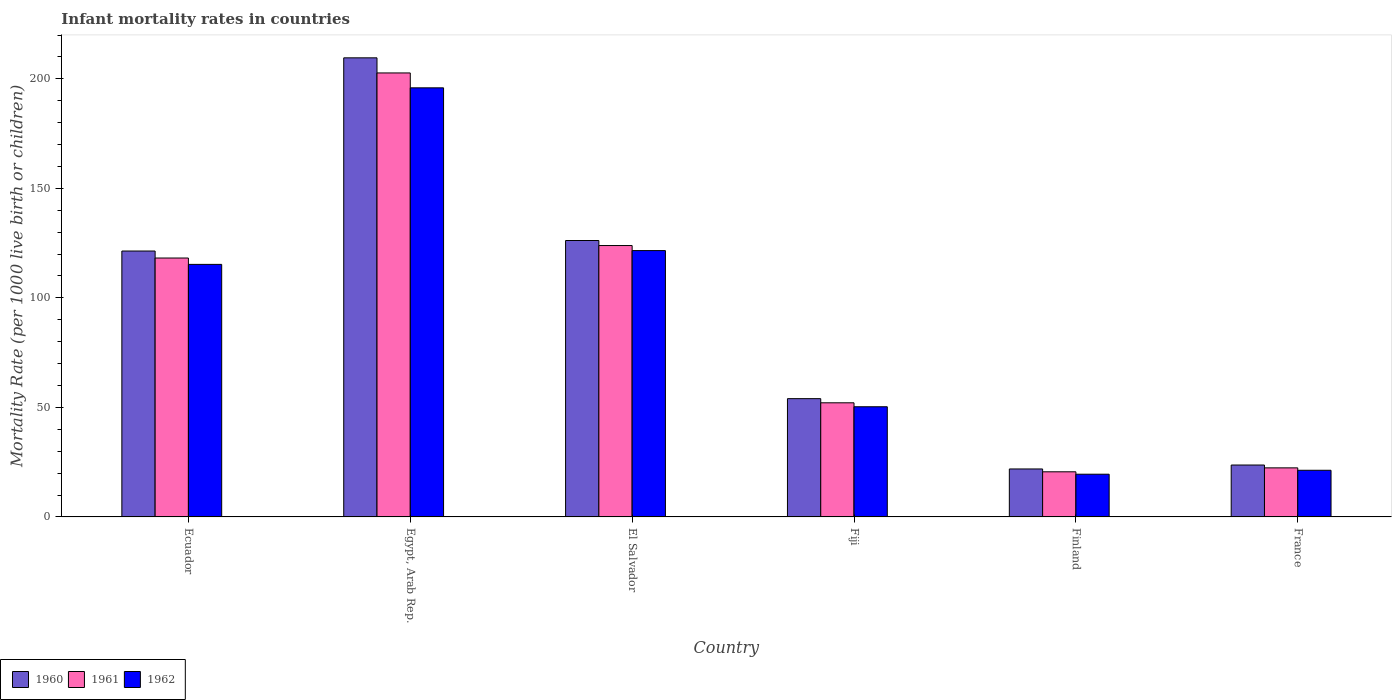How many different coloured bars are there?
Give a very brief answer. 3. How many groups of bars are there?
Keep it short and to the point. 6. Are the number of bars per tick equal to the number of legend labels?
Your answer should be compact. Yes. How many bars are there on the 4th tick from the left?
Provide a short and direct response. 3. How many bars are there on the 1st tick from the right?
Ensure brevity in your answer.  3. In how many cases, is the number of bars for a given country not equal to the number of legend labels?
Provide a succinct answer. 0. What is the infant mortality rate in 1962 in Egypt, Arab Rep.?
Your response must be concise. 195.9. Across all countries, what is the maximum infant mortality rate in 1960?
Your response must be concise. 209.6. Across all countries, what is the minimum infant mortality rate in 1961?
Give a very brief answer. 20.6. In which country was the infant mortality rate in 1961 maximum?
Your response must be concise. Egypt, Arab Rep. In which country was the infant mortality rate in 1962 minimum?
Offer a terse response. Finland. What is the total infant mortality rate in 1960 in the graph?
Offer a terse response. 556.8. What is the difference between the infant mortality rate in 1960 in El Salvador and that in Fiji?
Offer a very short reply. 72.2. What is the difference between the infant mortality rate in 1962 in El Salvador and the infant mortality rate in 1960 in Fiji?
Provide a succinct answer. 67.6. What is the average infant mortality rate in 1961 per country?
Your answer should be compact. 89.98. What is the difference between the infant mortality rate of/in 1961 and infant mortality rate of/in 1962 in Finland?
Give a very brief answer. 1.1. What is the ratio of the infant mortality rate in 1962 in Egypt, Arab Rep. to that in Finland?
Ensure brevity in your answer.  10.05. Is the infant mortality rate in 1962 in Ecuador less than that in El Salvador?
Provide a short and direct response. Yes. What is the difference between the highest and the second highest infant mortality rate in 1961?
Ensure brevity in your answer.  78.8. What is the difference between the highest and the lowest infant mortality rate in 1961?
Offer a very short reply. 182.1. What does the 1st bar from the left in Finland represents?
Your answer should be very brief. 1960. What does the 1st bar from the right in France represents?
Give a very brief answer. 1962. How many countries are there in the graph?
Keep it short and to the point. 6. Does the graph contain grids?
Keep it short and to the point. No. Where does the legend appear in the graph?
Offer a terse response. Bottom left. How are the legend labels stacked?
Make the answer very short. Horizontal. What is the title of the graph?
Offer a terse response. Infant mortality rates in countries. Does "1983" appear as one of the legend labels in the graph?
Provide a succinct answer. No. What is the label or title of the X-axis?
Provide a short and direct response. Country. What is the label or title of the Y-axis?
Provide a succinct answer. Mortality Rate (per 1000 live birth or children). What is the Mortality Rate (per 1000 live birth or children) of 1960 in Ecuador?
Ensure brevity in your answer.  121.4. What is the Mortality Rate (per 1000 live birth or children) of 1961 in Ecuador?
Your answer should be very brief. 118.2. What is the Mortality Rate (per 1000 live birth or children) of 1962 in Ecuador?
Offer a very short reply. 115.3. What is the Mortality Rate (per 1000 live birth or children) in 1960 in Egypt, Arab Rep.?
Ensure brevity in your answer.  209.6. What is the Mortality Rate (per 1000 live birth or children) in 1961 in Egypt, Arab Rep.?
Provide a short and direct response. 202.7. What is the Mortality Rate (per 1000 live birth or children) of 1962 in Egypt, Arab Rep.?
Offer a very short reply. 195.9. What is the Mortality Rate (per 1000 live birth or children) of 1960 in El Salvador?
Give a very brief answer. 126.2. What is the Mortality Rate (per 1000 live birth or children) of 1961 in El Salvador?
Keep it short and to the point. 123.9. What is the Mortality Rate (per 1000 live birth or children) of 1962 in El Salvador?
Offer a terse response. 121.6. What is the Mortality Rate (per 1000 live birth or children) of 1961 in Fiji?
Your response must be concise. 52.1. What is the Mortality Rate (per 1000 live birth or children) of 1962 in Fiji?
Ensure brevity in your answer.  50.3. What is the Mortality Rate (per 1000 live birth or children) of 1960 in Finland?
Keep it short and to the point. 21.9. What is the Mortality Rate (per 1000 live birth or children) of 1961 in Finland?
Give a very brief answer. 20.6. What is the Mortality Rate (per 1000 live birth or children) of 1960 in France?
Your response must be concise. 23.7. What is the Mortality Rate (per 1000 live birth or children) in 1961 in France?
Your answer should be very brief. 22.4. What is the Mortality Rate (per 1000 live birth or children) of 1962 in France?
Make the answer very short. 21.3. Across all countries, what is the maximum Mortality Rate (per 1000 live birth or children) in 1960?
Offer a terse response. 209.6. Across all countries, what is the maximum Mortality Rate (per 1000 live birth or children) in 1961?
Offer a terse response. 202.7. Across all countries, what is the maximum Mortality Rate (per 1000 live birth or children) in 1962?
Provide a short and direct response. 195.9. Across all countries, what is the minimum Mortality Rate (per 1000 live birth or children) of 1960?
Keep it short and to the point. 21.9. Across all countries, what is the minimum Mortality Rate (per 1000 live birth or children) of 1961?
Give a very brief answer. 20.6. Across all countries, what is the minimum Mortality Rate (per 1000 live birth or children) in 1962?
Provide a short and direct response. 19.5. What is the total Mortality Rate (per 1000 live birth or children) of 1960 in the graph?
Offer a terse response. 556.8. What is the total Mortality Rate (per 1000 live birth or children) of 1961 in the graph?
Make the answer very short. 539.9. What is the total Mortality Rate (per 1000 live birth or children) in 1962 in the graph?
Provide a short and direct response. 523.9. What is the difference between the Mortality Rate (per 1000 live birth or children) of 1960 in Ecuador and that in Egypt, Arab Rep.?
Your answer should be compact. -88.2. What is the difference between the Mortality Rate (per 1000 live birth or children) in 1961 in Ecuador and that in Egypt, Arab Rep.?
Your answer should be very brief. -84.5. What is the difference between the Mortality Rate (per 1000 live birth or children) in 1962 in Ecuador and that in Egypt, Arab Rep.?
Offer a very short reply. -80.6. What is the difference between the Mortality Rate (per 1000 live birth or children) of 1961 in Ecuador and that in El Salvador?
Your answer should be very brief. -5.7. What is the difference between the Mortality Rate (per 1000 live birth or children) in 1962 in Ecuador and that in El Salvador?
Offer a terse response. -6.3. What is the difference between the Mortality Rate (per 1000 live birth or children) of 1960 in Ecuador and that in Fiji?
Your answer should be compact. 67.4. What is the difference between the Mortality Rate (per 1000 live birth or children) in 1961 in Ecuador and that in Fiji?
Your answer should be compact. 66.1. What is the difference between the Mortality Rate (per 1000 live birth or children) of 1962 in Ecuador and that in Fiji?
Your answer should be very brief. 65. What is the difference between the Mortality Rate (per 1000 live birth or children) of 1960 in Ecuador and that in Finland?
Your answer should be compact. 99.5. What is the difference between the Mortality Rate (per 1000 live birth or children) of 1961 in Ecuador and that in Finland?
Give a very brief answer. 97.6. What is the difference between the Mortality Rate (per 1000 live birth or children) in 1962 in Ecuador and that in Finland?
Provide a short and direct response. 95.8. What is the difference between the Mortality Rate (per 1000 live birth or children) in 1960 in Ecuador and that in France?
Your response must be concise. 97.7. What is the difference between the Mortality Rate (per 1000 live birth or children) in 1961 in Ecuador and that in France?
Ensure brevity in your answer.  95.8. What is the difference between the Mortality Rate (per 1000 live birth or children) of 1962 in Ecuador and that in France?
Your answer should be very brief. 94. What is the difference between the Mortality Rate (per 1000 live birth or children) in 1960 in Egypt, Arab Rep. and that in El Salvador?
Make the answer very short. 83.4. What is the difference between the Mortality Rate (per 1000 live birth or children) in 1961 in Egypt, Arab Rep. and that in El Salvador?
Your answer should be very brief. 78.8. What is the difference between the Mortality Rate (per 1000 live birth or children) in 1962 in Egypt, Arab Rep. and that in El Salvador?
Your answer should be very brief. 74.3. What is the difference between the Mortality Rate (per 1000 live birth or children) in 1960 in Egypt, Arab Rep. and that in Fiji?
Your response must be concise. 155.6. What is the difference between the Mortality Rate (per 1000 live birth or children) in 1961 in Egypt, Arab Rep. and that in Fiji?
Your response must be concise. 150.6. What is the difference between the Mortality Rate (per 1000 live birth or children) in 1962 in Egypt, Arab Rep. and that in Fiji?
Your answer should be very brief. 145.6. What is the difference between the Mortality Rate (per 1000 live birth or children) in 1960 in Egypt, Arab Rep. and that in Finland?
Ensure brevity in your answer.  187.7. What is the difference between the Mortality Rate (per 1000 live birth or children) in 1961 in Egypt, Arab Rep. and that in Finland?
Keep it short and to the point. 182.1. What is the difference between the Mortality Rate (per 1000 live birth or children) of 1962 in Egypt, Arab Rep. and that in Finland?
Make the answer very short. 176.4. What is the difference between the Mortality Rate (per 1000 live birth or children) of 1960 in Egypt, Arab Rep. and that in France?
Your response must be concise. 185.9. What is the difference between the Mortality Rate (per 1000 live birth or children) in 1961 in Egypt, Arab Rep. and that in France?
Offer a very short reply. 180.3. What is the difference between the Mortality Rate (per 1000 live birth or children) of 1962 in Egypt, Arab Rep. and that in France?
Offer a very short reply. 174.6. What is the difference between the Mortality Rate (per 1000 live birth or children) in 1960 in El Salvador and that in Fiji?
Your answer should be very brief. 72.2. What is the difference between the Mortality Rate (per 1000 live birth or children) of 1961 in El Salvador and that in Fiji?
Ensure brevity in your answer.  71.8. What is the difference between the Mortality Rate (per 1000 live birth or children) of 1962 in El Salvador and that in Fiji?
Give a very brief answer. 71.3. What is the difference between the Mortality Rate (per 1000 live birth or children) of 1960 in El Salvador and that in Finland?
Offer a very short reply. 104.3. What is the difference between the Mortality Rate (per 1000 live birth or children) of 1961 in El Salvador and that in Finland?
Your answer should be compact. 103.3. What is the difference between the Mortality Rate (per 1000 live birth or children) in 1962 in El Salvador and that in Finland?
Your answer should be compact. 102.1. What is the difference between the Mortality Rate (per 1000 live birth or children) of 1960 in El Salvador and that in France?
Provide a succinct answer. 102.5. What is the difference between the Mortality Rate (per 1000 live birth or children) in 1961 in El Salvador and that in France?
Give a very brief answer. 101.5. What is the difference between the Mortality Rate (per 1000 live birth or children) of 1962 in El Salvador and that in France?
Your answer should be compact. 100.3. What is the difference between the Mortality Rate (per 1000 live birth or children) of 1960 in Fiji and that in Finland?
Give a very brief answer. 32.1. What is the difference between the Mortality Rate (per 1000 live birth or children) in 1961 in Fiji and that in Finland?
Keep it short and to the point. 31.5. What is the difference between the Mortality Rate (per 1000 live birth or children) in 1962 in Fiji and that in Finland?
Offer a very short reply. 30.8. What is the difference between the Mortality Rate (per 1000 live birth or children) in 1960 in Fiji and that in France?
Offer a terse response. 30.3. What is the difference between the Mortality Rate (per 1000 live birth or children) in 1961 in Fiji and that in France?
Ensure brevity in your answer.  29.7. What is the difference between the Mortality Rate (per 1000 live birth or children) of 1962 in Fiji and that in France?
Your answer should be compact. 29. What is the difference between the Mortality Rate (per 1000 live birth or children) in 1960 in Ecuador and the Mortality Rate (per 1000 live birth or children) in 1961 in Egypt, Arab Rep.?
Your answer should be compact. -81.3. What is the difference between the Mortality Rate (per 1000 live birth or children) of 1960 in Ecuador and the Mortality Rate (per 1000 live birth or children) of 1962 in Egypt, Arab Rep.?
Your answer should be very brief. -74.5. What is the difference between the Mortality Rate (per 1000 live birth or children) of 1961 in Ecuador and the Mortality Rate (per 1000 live birth or children) of 1962 in Egypt, Arab Rep.?
Provide a short and direct response. -77.7. What is the difference between the Mortality Rate (per 1000 live birth or children) of 1960 in Ecuador and the Mortality Rate (per 1000 live birth or children) of 1961 in El Salvador?
Your answer should be compact. -2.5. What is the difference between the Mortality Rate (per 1000 live birth or children) in 1960 in Ecuador and the Mortality Rate (per 1000 live birth or children) in 1962 in El Salvador?
Ensure brevity in your answer.  -0.2. What is the difference between the Mortality Rate (per 1000 live birth or children) in 1961 in Ecuador and the Mortality Rate (per 1000 live birth or children) in 1962 in El Salvador?
Your response must be concise. -3.4. What is the difference between the Mortality Rate (per 1000 live birth or children) in 1960 in Ecuador and the Mortality Rate (per 1000 live birth or children) in 1961 in Fiji?
Ensure brevity in your answer.  69.3. What is the difference between the Mortality Rate (per 1000 live birth or children) of 1960 in Ecuador and the Mortality Rate (per 1000 live birth or children) of 1962 in Fiji?
Make the answer very short. 71.1. What is the difference between the Mortality Rate (per 1000 live birth or children) of 1961 in Ecuador and the Mortality Rate (per 1000 live birth or children) of 1962 in Fiji?
Keep it short and to the point. 67.9. What is the difference between the Mortality Rate (per 1000 live birth or children) of 1960 in Ecuador and the Mortality Rate (per 1000 live birth or children) of 1961 in Finland?
Give a very brief answer. 100.8. What is the difference between the Mortality Rate (per 1000 live birth or children) of 1960 in Ecuador and the Mortality Rate (per 1000 live birth or children) of 1962 in Finland?
Give a very brief answer. 101.9. What is the difference between the Mortality Rate (per 1000 live birth or children) in 1961 in Ecuador and the Mortality Rate (per 1000 live birth or children) in 1962 in Finland?
Provide a succinct answer. 98.7. What is the difference between the Mortality Rate (per 1000 live birth or children) in 1960 in Ecuador and the Mortality Rate (per 1000 live birth or children) in 1961 in France?
Provide a short and direct response. 99. What is the difference between the Mortality Rate (per 1000 live birth or children) of 1960 in Ecuador and the Mortality Rate (per 1000 live birth or children) of 1962 in France?
Your response must be concise. 100.1. What is the difference between the Mortality Rate (per 1000 live birth or children) in 1961 in Ecuador and the Mortality Rate (per 1000 live birth or children) in 1962 in France?
Your answer should be very brief. 96.9. What is the difference between the Mortality Rate (per 1000 live birth or children) of 1960 in Egypt, Arab Rep. and the Mortality Rate (per 1000 live birth or children) of 1961 in El Salvador?
Your answer should be compact. 85.7. What is the difference between the Mortality Rate (per 1000 live birth or children) in 1961 in Egypt, Arab Rep. and the Mortality Rate (per 1000 live birth or children) in 1962 in El Salvador?
Your response must be concise. 81.1. What is the difference between the Mortality Rate (per 1000 live birth or children) in 1960 in Egypt, Arab Rep. and the Mortality Rate (per 1000 live birth or children) in 1961 in Fiji?
Offer a very short reply. 157.5. What is the difference between the Mortality Rate (per 1000 live birth or children) in 1960 in Egypt, Arab Rep. and the Mortality Rate (per 1000 live birth or children) in 1962 in Fiji?
Your answer should be very brief. 159.3. What is the difference between the Mortality Rate (per 1000 live birth or children) of 1961 in Egypt, Arab Rep. and the Mortality Rate (per 1000 live birth or children) of 1962 in Fiji?
Make the answer very short. 152.4. What is the difference between the Mortality Rate (per 1000 live birth or children) of 1960 in Egypt, Arab Rep. and the Mortality Rate (per 1000 live birth or children) of 1961 in Finland?
Keep it short and to the point. 189. What is the difference between the Mortality Rate (per 1000 live birth or children) in 1960 in Egypt, Arab Rep. and the Mortality Rate (per 1000 live birth or children) in 1962 in Finland?
Offer a very short reply. 190.1. What is the difference between the Mortality Rate (per 1000 live birth or children) of 1961 in Egypt, Arab Rep. and the Mortality Rate (per 1000 live birth or children) of 1962 in Finland?
Offer a very short reply. 183.2. What is the difference between the Mortality Rate (per 1000 live birth or children) in 1960 in Egypt, Arab Rep. and the Mortality Rate (per 1000 live birth or children) in 1961 in France?
Provide a short and direct response. 187.2. What is the difference between the Mortality Rate (per 1000 live birth or children) in 1960 in Egypt, Arab Rep. and the Mortality Rate (per 1000 live birth or children) in 1962 in France?
Give a very brief answer. 188.3. What is the difference between the Mortality Rate (per 1000 live birth or children) in 1961 in Egypt, Arab Rep. and the Mortality Rate (per 1000 live birth or children) in 1962 in France?
Give a very brief answer. 181.4. What is the difference between the Mortality Rate (per 1000 live birth or children) of 1960 in El Salvador and the Mortality Rate (per 1000 live birth or children) of 1961 in Fiji?
Give a very brief answer. 74.1. What is the difference between the Mortality Rate (per 1000 live birth or children) of 1960 in El Salvador and the Mortality Rate (per 1000 live birth or children) of 1962 in Fiji?
Give a very brief answer. 75.9. What is the difference between the Mortality Rate (per 1000 live birth or children) of 1961 in El Salvador and the Mortality Rate (per 1000 live birth or children) of 1962 in Fiji?
Keep it short and to the point. 73.6. What is the difference between the Mortality Rate (per 1000 live birth or children) of 1960 in El Salvador and the Mortality Rate (per 1000 live birth or children) of 1961 in Finland?
Provide a succinct answer. 105.6. What is the difference between the Mortality Rate (per 1000 live birth or children) in 1960 in El Salvador and the Mortality Rate (per 1000 live birth or children) in 1962 in Finland?
Keep it short and to the point. 106.7. What is the difference between the Mortality Rate (per 1000 live birth or children) in 1961 in El Salvador and the Mortality Rate (per 1000 live birth or children) in 1962 in Finland?
Make the answer very short. 104.4. What is the difference between the Mortality Rate (per 1000 live birth or children) of 1960 in El Salvador and the Mortality Rate (per 1000 live birth or children) of 1961 in France?
Keep it short and to the point. 103.8. What is the difference between the Mortality Rate (per 1000 live birth or children) in 1960 in El Salvador and the Mortality Rate (per 1000 live birth or children) in 1962 in France?
Offer a very short reply. 104.9. What is the difference between the Mortality Rate (per 1000 live birth or children) in 1961 in El Salvador and the Mortality Rate (per 1000 live birth or children) in 1962 in France?
Ensure brevity in your answer.  102.6. What is the difference between the Mortality Rate (per 1000 live birth or children) in 1960 in Fiji and the Mortality Rate (per 1000 live birth or children) in 1961 in Finland?
Your answer should be very brief. 33.4. What is the difference between the Mortality Rate (per 1000 live birth or children) of 1960 in Fiji and the Mortality Rate (per 1000 live birth or children) of 1962 in Finland?
Keep it short and to the point. 34.5. What is the difference between the Mortality Rate (per 1000 live birth or children) in 1961 in Fiji and the Mortality Rate (per 1000 live birth or children) in 1962 in Finland?
Ensure brevity in your answer.  32.6. What is the difference between the Mortality Rate (per 1000 live birth or children) in 1960 in Fiji and the Mortality Rate (per 1000 live birth or children) in 1961 in France?
Give a very brief answer. 31.6. What is the difference between the Mortality Rate (per 1000 live birth or children) of 1960 in Fiji and the Mortality Rate (per 1000 live birth or children) of 1962 in France?
Make the answer very short. 32.7. What is the difference between the Mortality Rate (per 1000 live birth or children) of 1961 in Fiji and the Mortality Rate (per 1000 live birth or children) of 1962 in France?
Ensure brevity in your answer.  30.8. What is the difference between the Mortality Rate (per 1000 live birth or children) of 1960 in Finland and the Mortality Rate (per 1000 live birth or children) of 1961 in France?
Make the answer very short. -0.5. What is the difference between the Mortality Rate (per 1000 live birth or children) in 1961 in Finland and the Mortality Rate (per 1000 live birth or children) in 1962 in France?
Provide a short and direct response. -0.7. What is the average Mortality Rate (per 1000 live birth or children) of 1960 per country?
Your answer should be very brief. 92.8. What is the average Mortality Rate (per 1000 live birth or children) in 1961 per country?
Offer a terse response. 89.98. What is the average Mortality Rate (per 1000 live birth or children) in 1962 per country?
Provide a succinct answer. 87.32. What is the difference between the Mortality Rate (per 1000 live birth or children) of 1960 and Mortality Rate (per 1000 live birth or children) of 1961 in Ecuador?
Your answer should be very brief. 3.2. What is the difference between the Mortality Rate (per 1000 live birth or children) in 1960 and Mortality Rate (per 1000 live birth or children) in 1962 in Egypt, Arab Rep.?
Provide a succinct answer. 13.7. What is the difference between the Mortality Rate (per 1000 live birth or children) in 1960 and Mortality Rate (per 1000 live birth or children) in 1961 in El Salvador?
Keep it short and to the point. 2.3. What is the difference between the Mortality Rate (per 1000 live birth or children) of 1960 and Mortality Rate (per 1000 live birth or children) of 1962 in El Salvador?
Give a very brief answer. 4.6. What is the difference between the Mortality Rate (per 1000 live birth or children) of 1960 and Mortality Rate (per 1000 live birth or children) of 1962 in Fiji?
Ensure brevity in your answer.  3.7. What is the difference between the Mortality Rate (per 1000 live birth or children) of 1961 and Mortality Rate (per 1000 live birth or children) of 1962 in Fiji?
Give a very brief answer. 1.8. What is the difference between the Mortality Rate (per 1000 live birth or children) of 1960 and Mortality Rate (per 1000 live birth or children) of 1962 in France?
Provide a short and direct response. 2.4. What is the ratio of the Mortality Rate (per 1000 live birth or children) in 1960 in Ecuador to that in Egypt, Arab Rep.?
Ensure brevity in your answer.  0.58. What is the ratio of the Mortality Rate (per 1000 live birth or children) in 1961 in Ecuador to that in Egypt, Arab Rep.?
Your response must be concise. 0.58. What is the ratio of the Mortality Rate (per 1000 live birth or children) of 1962 in Ecuador to that in Egypt, Arab Rep.?
Provide a succinct answer. 0.59. What is the ratio of the Mortality Rate (per 1000 live birth or children) in 1960 in Ecuador to that in El Salvador?
Make the answer very short. 0.96. What is the ratio of the Mortality Rate (per 1000 live birth or children) of 1961 in Ecuador to that in El Salvador?
Offer a very short reply. 0.95. What is the ratio of the Mortality Rate (per 1000 live birth or children) of 1962 in Ecuador to that in El Salvador?
Your answer should be very brief. 0.95. What is the ratio of the Mortality Rate (per 1000 live birth or children) in 1960 in Ecuador to that in Fiji?
Offer a very short reply. 2.25. What is the ratio of the Mortality Rate (per 1000 live birth or children) in 1961 in Ecuador to that in Fiji?
Keep it short and to the point. 2.27. What is the ratio of the Mortality Rate (per 1000 live birth or children) in 1962 in Ecuador to that in Fiji?
Your answer should be compact. 2.29. What is the ratio of the Mortality Rate (per 1000 live birth or children) of 1960 in Ecuador to that in Finland?
Your answer should be very brief. 5.54. What is the ratio of the Mortality Rate (per 1000 live birth or children) in 1961 in Ecuador to that in Finland?
Give a very brief answer. 5.74. What is the ratio of the Mortality Rate (per 1000 live birth or children) of 1962 in Ecuador to that in Finland?
Your response must be concise. 5.91. What is the ratio of the Mortality Rate (per 1000 live birth or children) in 1960 in Ecuador to that in France?
Your response must be concise. 5.12. What is the ratio of the Mortality Rate (per 1000 live birth or children) of 1961 in Ecuador to that in France?
Provide a succinct answer. 5.28. What is the ratio of the Mortality Rate (per 1000 live birth or children) of 1962 in Ecuador to that in France?
Keep it short and to the point. 5.41. What is the ratio of the Mortality Rate (per 1000 live birth or children) of 1960 in Egypt, Arab Rep. to that in El Salvador?
Keep it short and to the point. 1.66. What is the ratio of the Mortality Rate (per 1000 live birth or children) in 1961 in Egypt, Arab Rep. to that in El Salvador?
Make the answer very short. 1.64. What is the ratio of the Mortality Rate (per 1000 live birth or children) in 1962 in Egypt, Arab Rep. to that in El Salvador?
Offer a very short reply. 1.61. What is the ratio of the Mortality Rate (per 1000 live birth or children) in 1960 in Egypt, Arab Rep. to that in Fiji?
Give a very brief answer. 3.88. What is the ratio of the Mortality Rate (per 1000 live birth or children) in 1961 in Egypt, Arab Rep. to that in Fiji?
Ensure brevity in your answer.  3.89. What is the ratio of the Mortality Rate (per 1000 live birth or children) in 1962 in Egypt, Arab Rep. to that in Fiji?
Your response must be concise. 3.89. What is the ratio of the Mortality Rate (per 1000 live birth or children) in 1960 in Egypt, Arab Rep. to that in Finland?
Offer a terse response. 9.57. What is the ratio of the Mortality Rate (per 1000 live birth or children) of 1961 in Egypt, Arab Rep. to that in Finland?
Your answer should be compact. 9.84. What is the ratio of the Mortality Rate (per 1000 live birth or children) of 1962 in Egypt, Arab Rep. to that in Finland?
Offer a very short reply. 10.05. What is the ratio of the Mortality Rate (per 1000 live birth or children) in 1960 in Egypt, Arab Rep. to that in France?
Your answer should be compact. 8.84. What is the ratio of the Mortality Rate (per 1000 live birth or children) of 1961 in Egypt, Arab Rep. to that in France?
Ensure brevity in your answer.  9.05. What is the ratio of the Mortality Rate (per 1000 live birth or children) of 1962 in Egypt, Arab Rep. to that in France?
Provide a succinct answer. 9.2. What is the ratio of the Mortality Rate (per 1000 live birth or children) in 1960 in El Salvador to that in Fiji?
Provide a short and direct response. 2.34. What is the ratio of the Mortality Rate (per 1000 live birth or children) of 1961 in El Salvador to that in Fiji?
Make the answer very short. 2.38. What is the ratio of the Mortality Rate (per 1000 live birth or children) in 1962 in El Salvador to that in Fiji?
Provide a succinct answer. 2.42. What is the ratio of the Mortality Rate (per 1000 live birth or children) of 1960 in El Salvador to that in Finland?
Your answer should be very brief. 5.76. What is the ratio of the Mortality Rate (per 1000 live birth or children) in 1961 in El Salvador to that in Finland?
Offer a very short reply. 6.01. What is the ratio of the Mortality Rate (per 1000 live birth or children) in 1962 in El Salvador to that in Finland?
Make the answer very short. 6.24. What is the ratio of the Mortality Rate (per 1000 live birth or children) in 1960 in El Salvador to that in France?
Ensure brevity in your answer.  5.32. What is the ratio of the Mortality Rate (per 1000 live birth or children) of 1961 in El Salvador to that in France?
Give a very brief answer. 5.53. What is the ratio of the Mortality Rate (per 1000 live birth or children) in 1962 in El Salvador to that in France?
Ensure brevity in your answer.  5.71. What is the ratio of the Mortality Rate (per 1000 live birth or children) of 1960 in Fiji to that in Finland?
Your response must be concise. 2.47. What is the ratio of the Mortality Rate (per 1000 live birth or children) in 1961 in Fiji to that in Finland?
Provide a short and direct response. 2.53. What is the ratio of the Mortality Rate (per 1000 live birth or children) in 1962 in Fiji to that in Finland?
Your answer should be compact. 2.58. What is the ratio of the Mortality Rate (per 1000 live birth or children) of 1960 in Fiji to that in France?
Offer a very short reply. 2.28. What is the ratio of the Mortality Rate (per 1000 live birth or children) in 1961 in Fiji to that in France?
Your answer should be very brief. 2.33. What is the ratio of the Mortality Rate (per 1000 live birth or children) in 1962 in Fiji to that in France?
Make the answer very short. 2.36. What is the ratio of the Mortality Rate (per 1000 live birth or children) of 1960 in Finland to that in France?
Your answer should be very brief. 0.92. What is the ratio of the Mortality Rate (per 1000 live birth or children) in 1961 in Finland to that in France?
Provide a short and direct response. 0.92. What is the ratio of the Mortality Rate (per 1000 live birth or children) of 1962 in Finland to that in France?
Offer a terse response. 0.92. What is the difference between the highest and the second highest Mortality Rate (per 1000 live birth or children) in 1960?
Provide a short and direct response. 83.4. What is the difference between the highest and the second highest Mortality Rate (per 1000 live birth or children) of 1961?
Provide a succinct answer. 78.8. What is the difference between the highest and the second highest Mortality Rate (per 1000 live birth or children) of 1962?
Provide a succinct answer. 74.3. What is the difference between the highest and the lowest Mortality Rate (per 1000 live birth or children) in 1960?
Your response must be concise. 187.7. What is the difference between the highest and the lowest Mortality Rate (per 1000 live birth or children) of 1961?
Give a very brief answer. 182.1. What is the difference between the highest and the lowest Mortality Rate (per 1000 live birth or children) in 1962?
Offer a terse response. 176.4. 